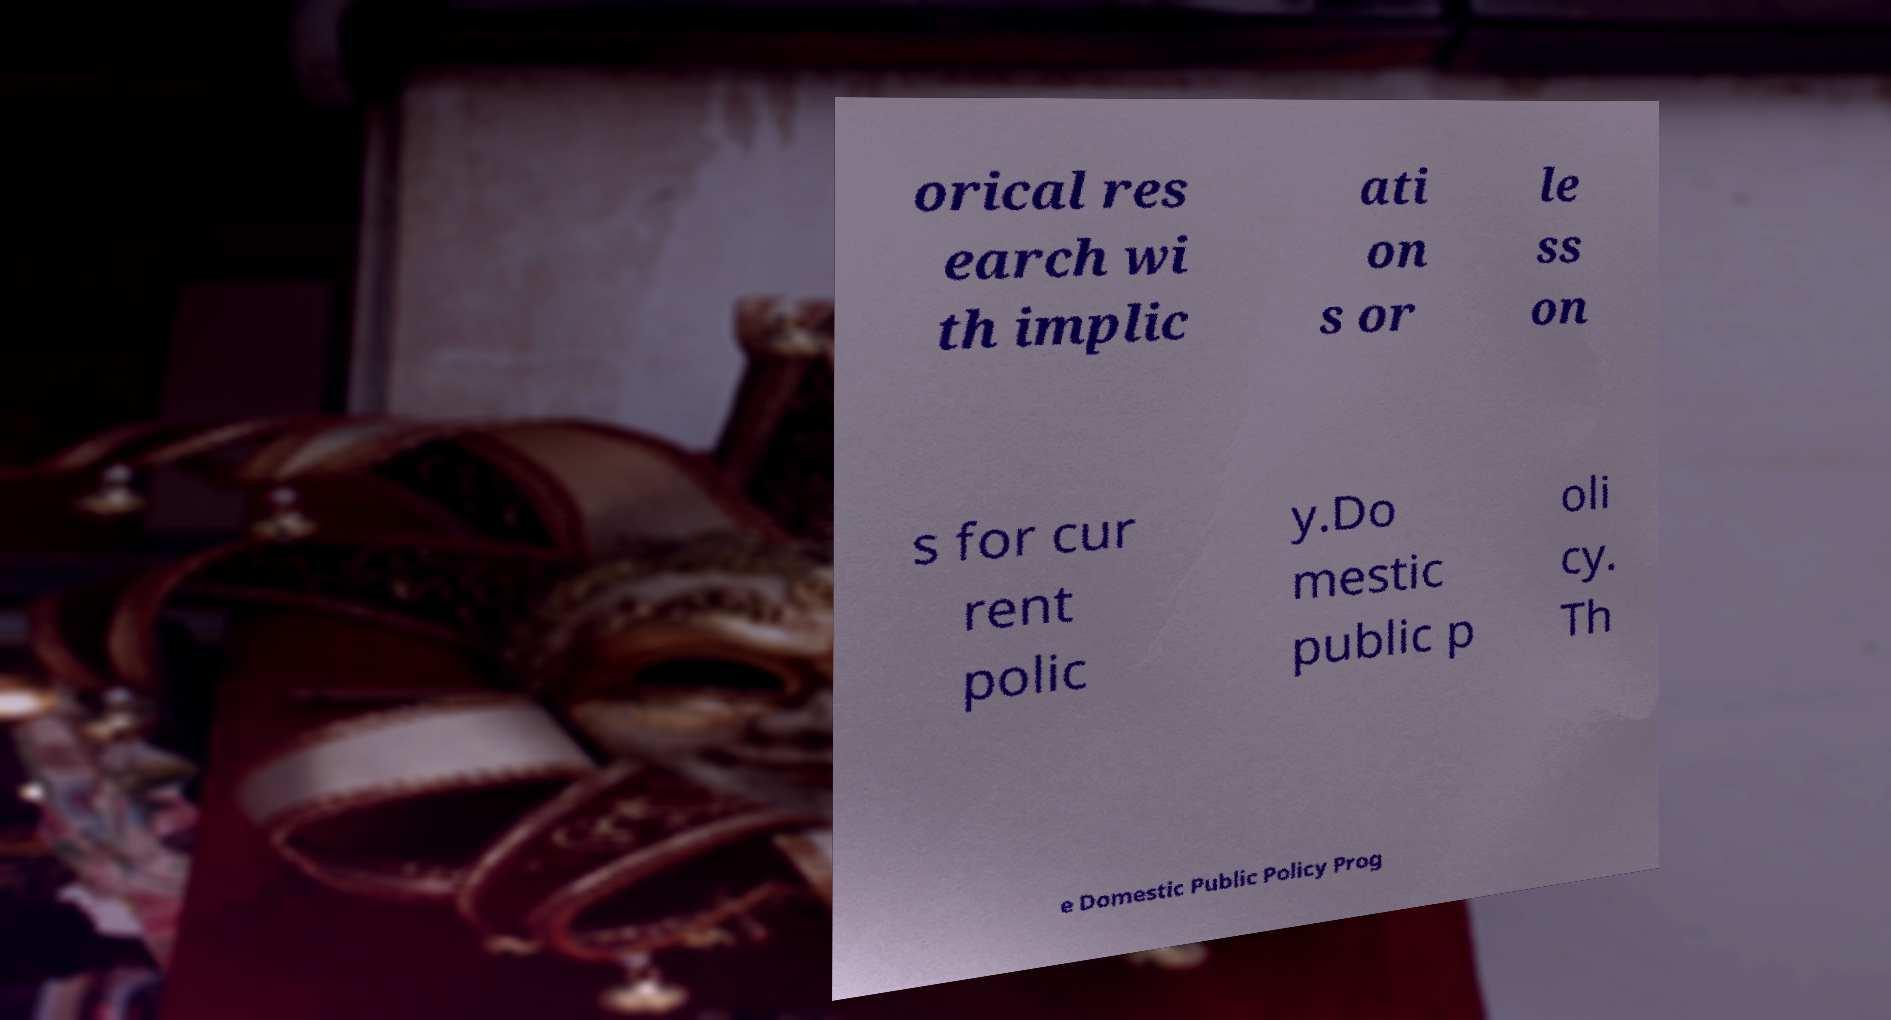Can you read and provide the text displayed in the image?This photo seems to have some interesting text. Can you extract and type it out for me? orical res earch wi th implic ati on s or le ss on s for cur rent polic y.Do mestic public p oli cy. Th e Domestic Public Policy Prog 